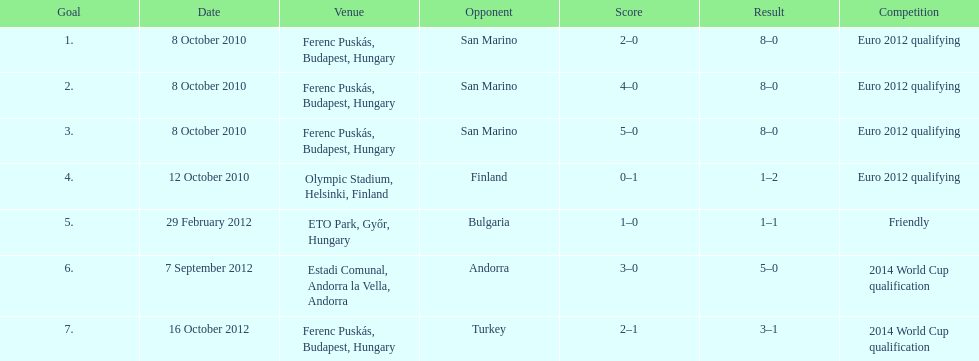Which country has szalai scored only one more international goal against compared to the sum of his goals against all other countries? San Marino. 